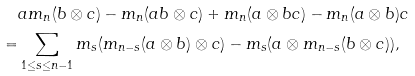<formula> <loc_0><loc_0><loc_500><loc_500>& a m _ { n } ( b \otimes c ) - m _ { n } ( a b \otimes c ) + m _ { n } ( a \otimes b c ) - m _ { n } ( a \otimes b ) c \\ = & \sum _ { 1 \leq s \leq n - 1 } m _ { s } ( m _ { n - s } ( a \otimes b ) \otimes c ) - m _ { s } ( a \otimes m _ { n - s } ( b \otimes c ) ) ,</formula> 